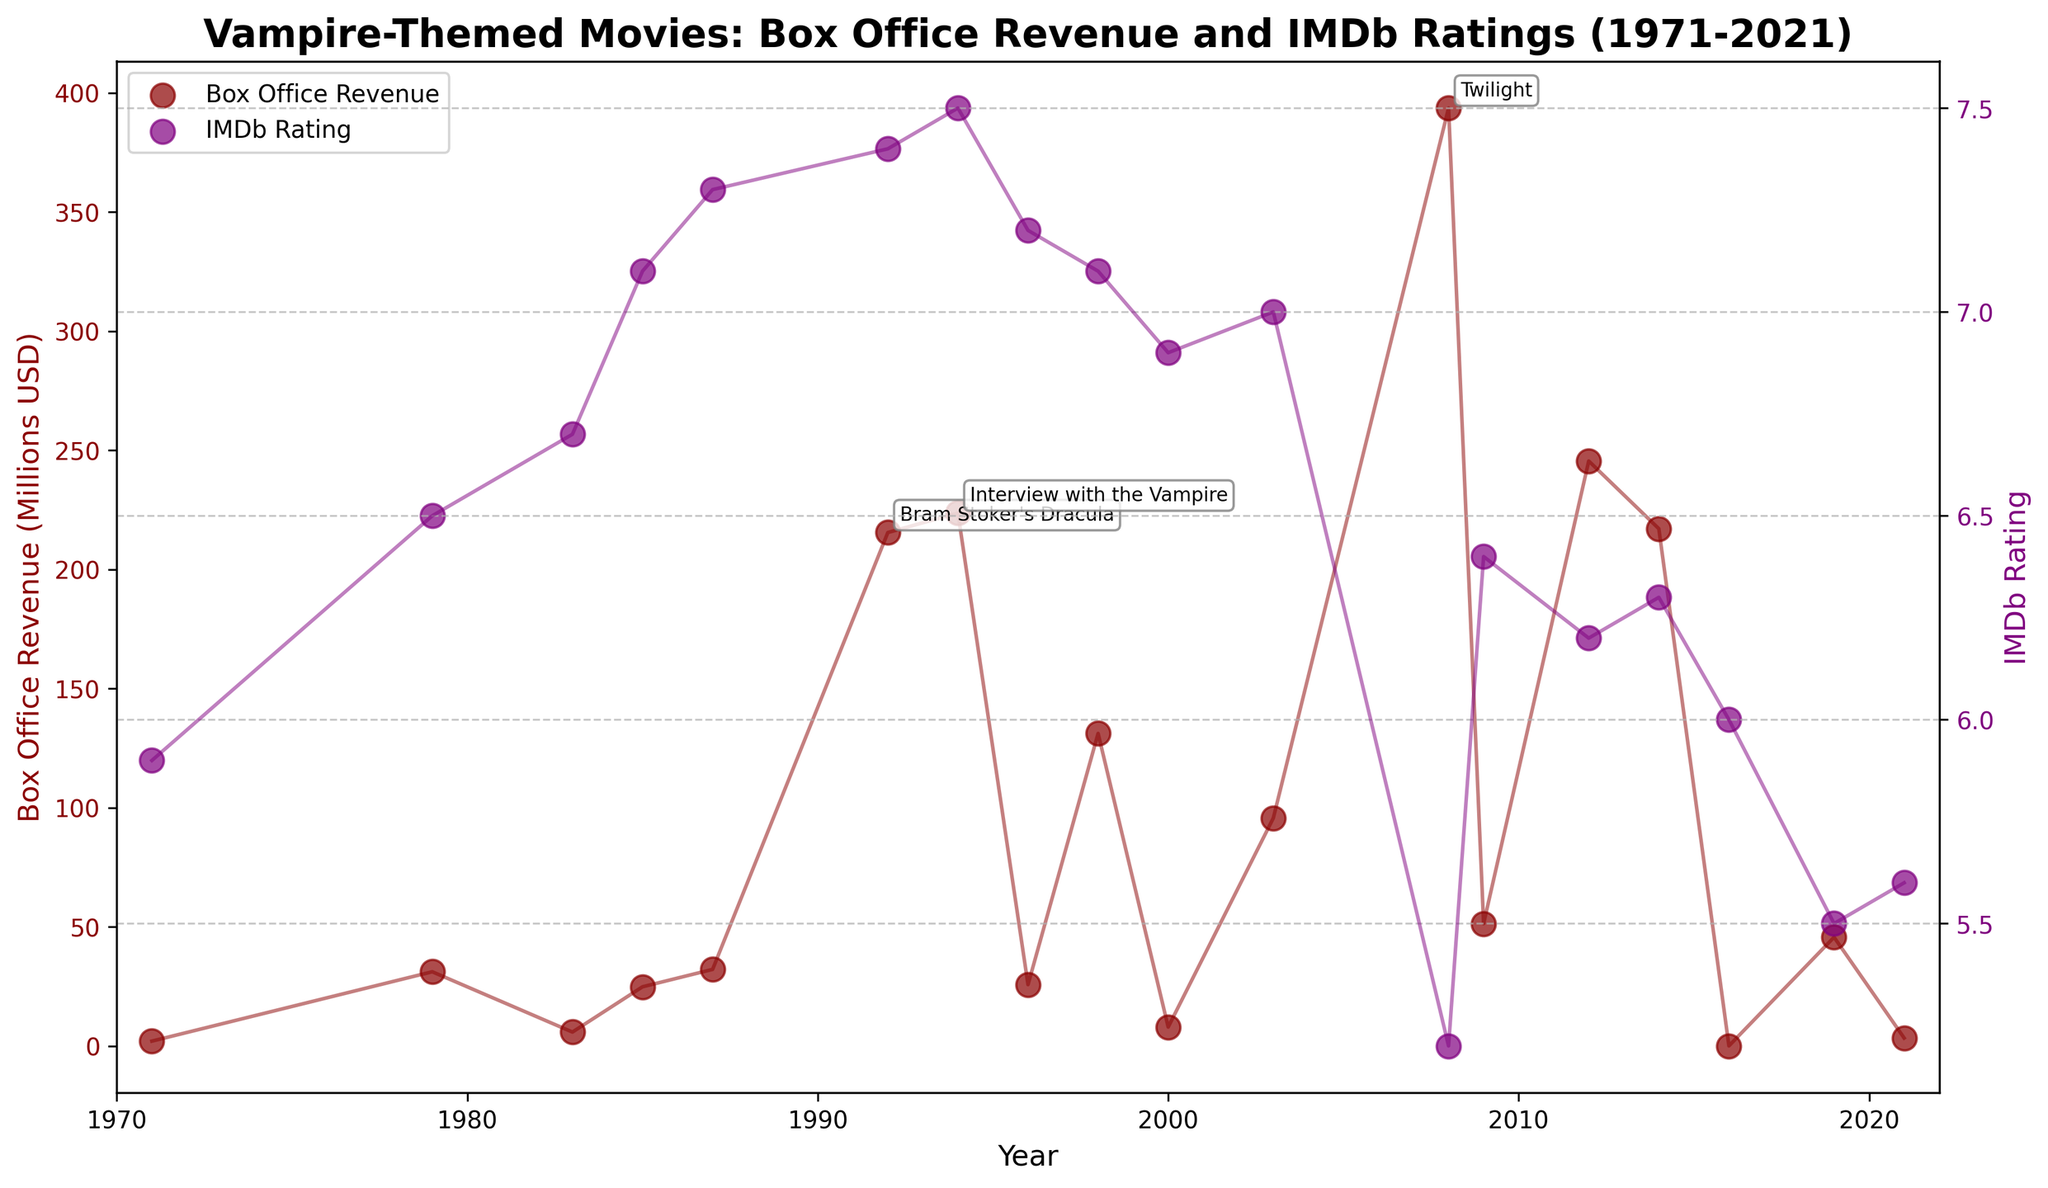How many vampire-themed movies are plotted on the figure? By counting each data point on the plot that represents a vampire-themed movie, we see there are 18 different movies represented.
Answer: 18 Which vampire-themed movie has the highest box office revenue? By looking at the peak point on the box office revenue plot, "Twilight" (2008) is the movie with the highest box office revenue.
Answer: Twilight Which year saw both significant box office revenue and a high IMDb rating? By identifying overlapping peaks in both series, "Interview with the Vampire" from 1994 shows high values in both box office revenue and IMDb rating.
Answer: 1994 What is the trend in IMDb ratings for vampire-themed movies from 1971 to 2021? The IMDb ratings initially show fluctuating values with some peaks, and then there appears to be a decline after the release of "Twilight" in 2008.
Answer: Declining How does "Bram Stoker's Dracula" (1992) compare in terms of box office revenue and IMDb rating to "Twilight" (2008)? "Bram Stoker's Dracula" has a lower box office revenue compared to "Twilight" but has a higher IMDb rating.
Answer: Lower revenue, higher rating What is the average IMDb rating for the vampire-themed movies released in the 2000s (2000-2009)? The IMDb ratings for the movies in the 2000s are 6.9, 7.0, 5.2, and 6.4. Summing these and dividing by 4 gives an average of (6.9 + 7.0 + 5.2 + 6.4) / 4 = 6.375.
Answer: 6.375 Which movie had the lowest box office revenue in the last 10 years? Inspecting the lower part of the y-axis for box office revenue in the last decade, "The Transfiguration" (2016) had the lowest revenue.
Answer: The Transfiguration How many movies have an IMDb rating above 7? By checking the IMDb rating axis, "Fright Night" (1985), "The Lost Boys" (1987), "Bram Stoker's Dracula" (1992), "Interview with the Vampire" (1994), and "From Dusk Till Dawn" (1996) have ratings above 7, totaling 5 movies.
Answer: 5 Which year shows the biggest difference between box office revenue and IMDb rating, and what are the respective values? In 2008, "Twilight" shows the biggest difference with a box office revenue of 393.6 million USD and an IMDb rating of 5.2.
Answer: 2008, 393.6 million USD, 5.2 Is there a relationship between box office revenue and IMDb ratings across the years? By observing the trends, there is no direct correlation as some high-revenue movies have low ratings and vice versa, indicating box office and ratings do not always align.
Answer: No direct correlation 